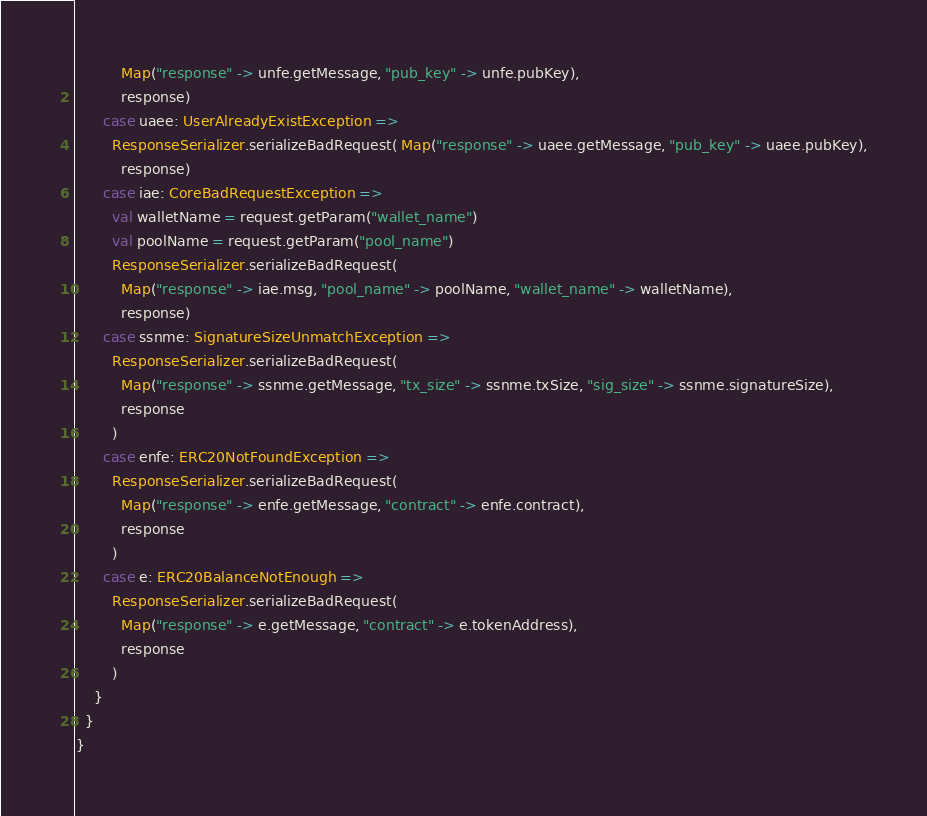Convert code to text. <code><loc_0><loc_0><loc_500><loc_500><_Scala_>          Map("response" -> unfe.getMessage, "pub_key" -> unfe.pubKey),
          response)
      case uaee: UserAlreadyExistException =>
        ResponseSerializer.serializeBadRequest( Map("response" -> uaee.getMessage, "pub_key" -> uaee.pubKey),
          response)
      case iae: CoreBadRequestException =>
        val walletName = request.getParam("wallet_name")
        val poolName = request.getParam("pool_name")
        ResponseSerializer.serializeBadRequest(
          Map("response" -> iae.msg, "pool_name" -> poolName, "wallet_name" -> walletName),
          response)
      case ssnme: SignatureSizeUnmatchException =>
        ResponseSerializer.serializeBadRequest(
          Map("response" -> ssnme.getMessage, "tx_size" -> ssnme.txSize, "sig_size" -> ssnme.signatureSize),
          response
        )
      case enfe: ERC20NotFoundException =>
        ResponseSerializer.serializeBadRequest(
          Map("response" -> enfe.getMessage, "contract" -> enfe.contract),
          response
        )
      case e: ERC20BalanceNotEnough =>
        ResponseSerializer.serializeBadRequest(
          Map("response" -> e.getMessage, "contract" -> e.tokenAddress),
          response
        )
    }
  }
}
</code> 